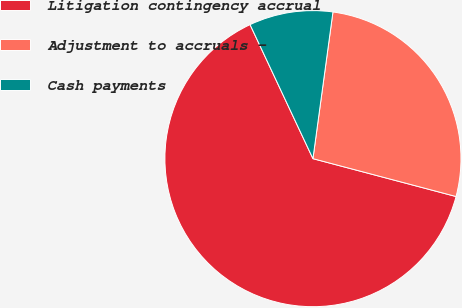Convert chart. <chart><loc_0><loc_0><loc_500><loc_500><pie_chart><fcel>Litigation contingency accrual<fcel>Adjustment to accruals -<fcel>Cash payments<nl><fcel>63.9%<fcel>26.96%<fcel>9.14%<nl></chart> 